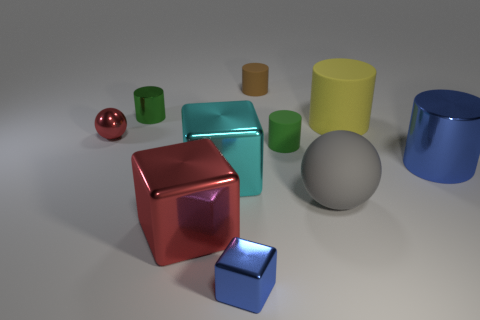How many objects have a cube-like shape? In this image, we see two objects that have a cube-like shape. The first is a large, shiny red cube in the center, and the second is a smaller, matte blue cube positioned toward the foreground on the right side. 